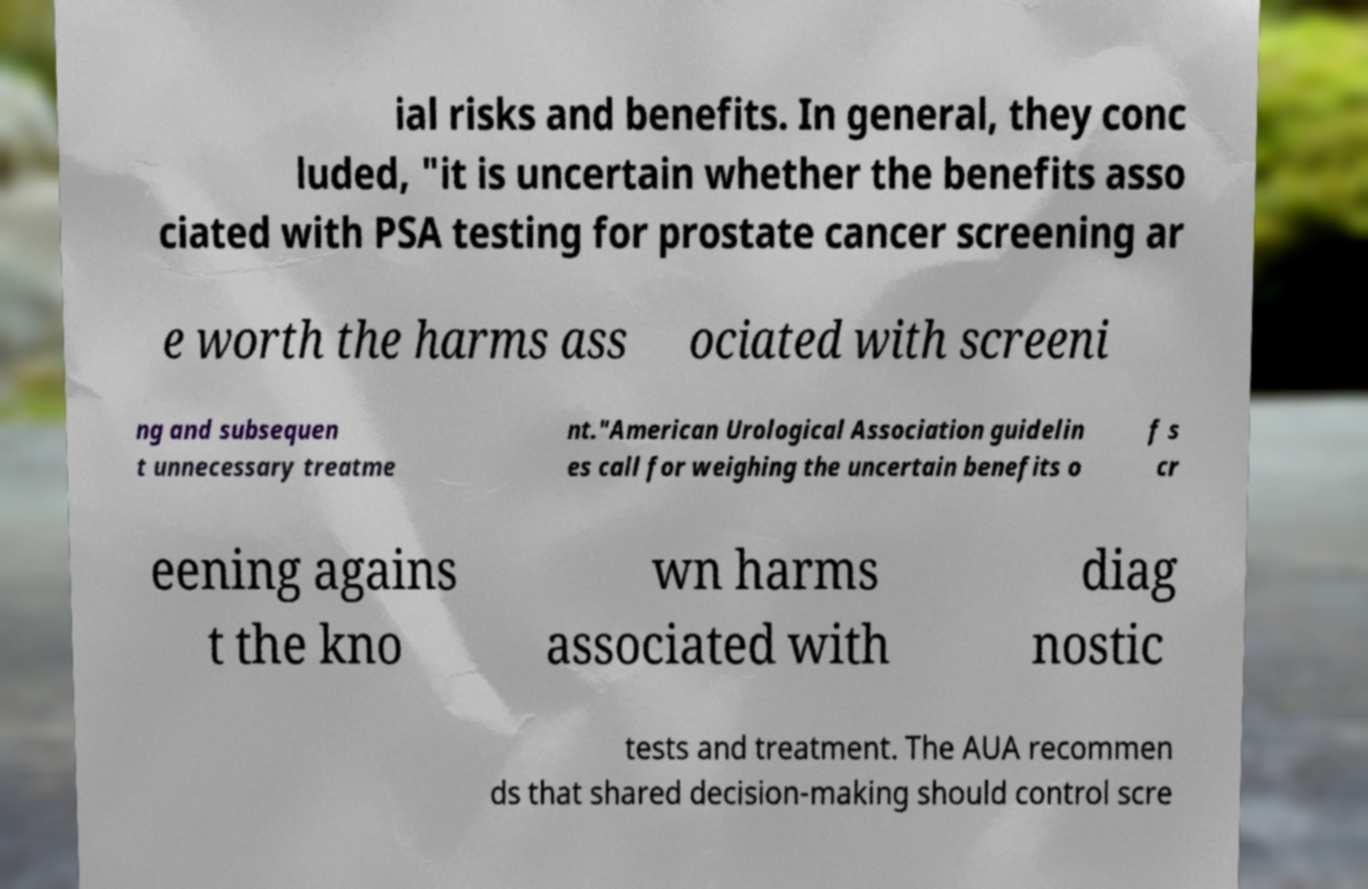For documentation purposes, I need the text within this image transcribed. Could you provide that? ial risks and benefits. In general, they conc luded, "it is uncertain whether the benefits asso ciated with PSA testing for prostate cancer screening ar e worth the harms ass ociated with screeni ng and subsequen t unnecessary treatme nt."American Urological Association guidelin es call for weighing the uncertain benefits o f s cr eening agains t the kno wn harms associated with diag nostic tests and treatment. The AUA recommen ds that shared decision-making should control scre 